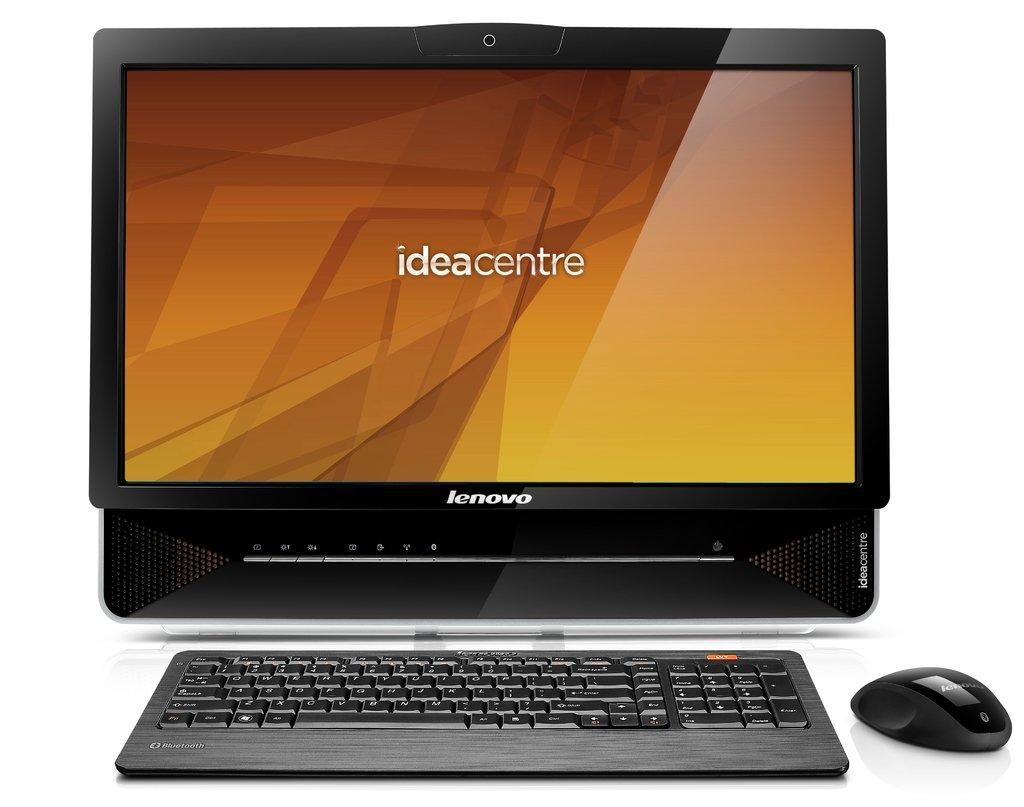<image>
Render a clear and concise summary of the photo. Lenovo desktop computer which is of the ideacentre model. 